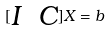<formula> <loc_0><loc_0><loc_500><loc_500>[ \begin{matrix} I & C \end{matrix} ] X = b</formula> 